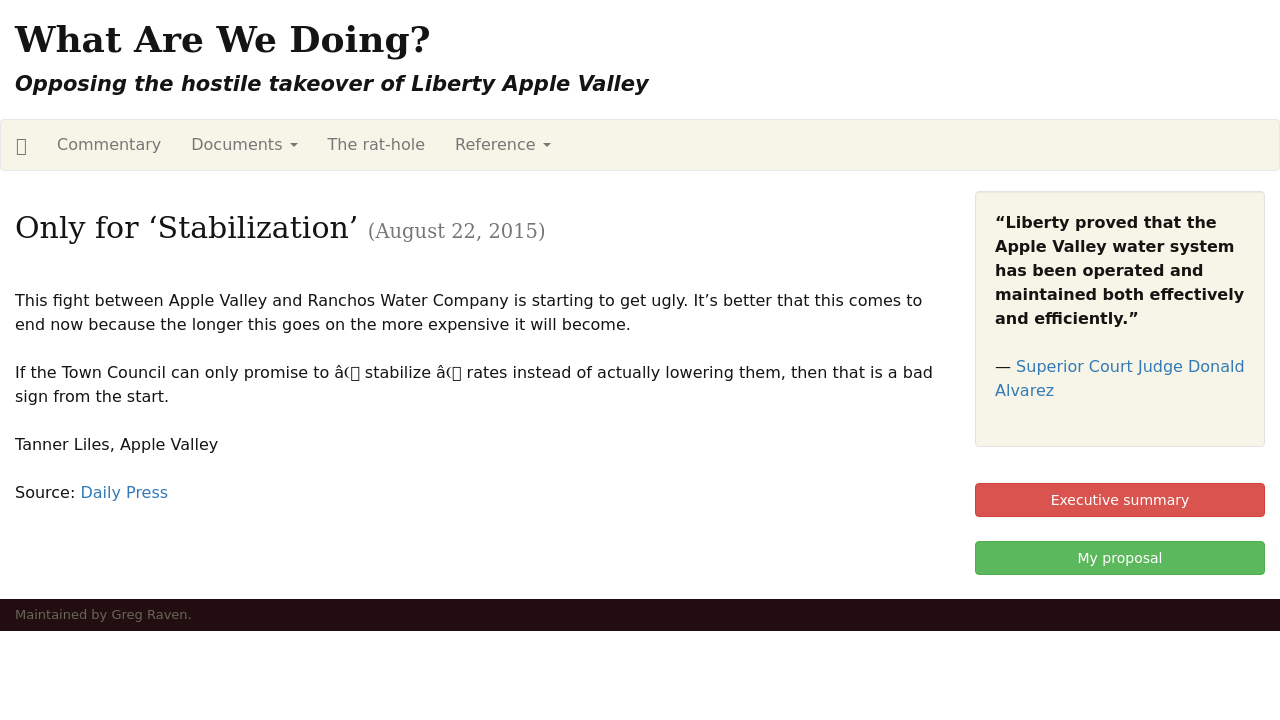How can I start building this website with HTML from the ground up? To start building a website with HTML from the ground up, begin by creating a basic HTML document structure. Use the <!DOCTYPE html> declaration to define the HTML version, and enclose the contents of your page within <html> tags. Inside, separate your document into the <head> section, for meta tags and links to CSS files, and the <body> section, where your website's visible content will go. For a simple website, you can start with a header, navigation links, a main content area, and a footer. Here’s a basic example:

<!DOCTYPE html>
<html>
<head>
    <title>Your Website Title</title>
</head>
<body>
    <header>
        <h1>Welcome to My Website</h1>
    </header>
    <nav>
        <ul>
            <li><a href="#home">Home</a></li>
            <li><a href="#services">Services</a></li>
            <li><a href="#about">About</a></li>
            <li><a href="#contact">Contact</a></li>
        </ul>
    </nav>
    <main>
        <section>
            <h2>About Us</h2>
            <p>Information about your services.</p>
        </section>
        <section>
            <h2>Contact Us</h2>
            <p>Details on how to contact us.</p>
        </section>
    </main>
    <footer>
        <p>Copyright 2023 Your Website.</p>
    </footer>
</body>
</html>

This structure is the foundation of your website, to which you can add more complex elements and functionality with additional HTML, CSS, and JavaScript. 